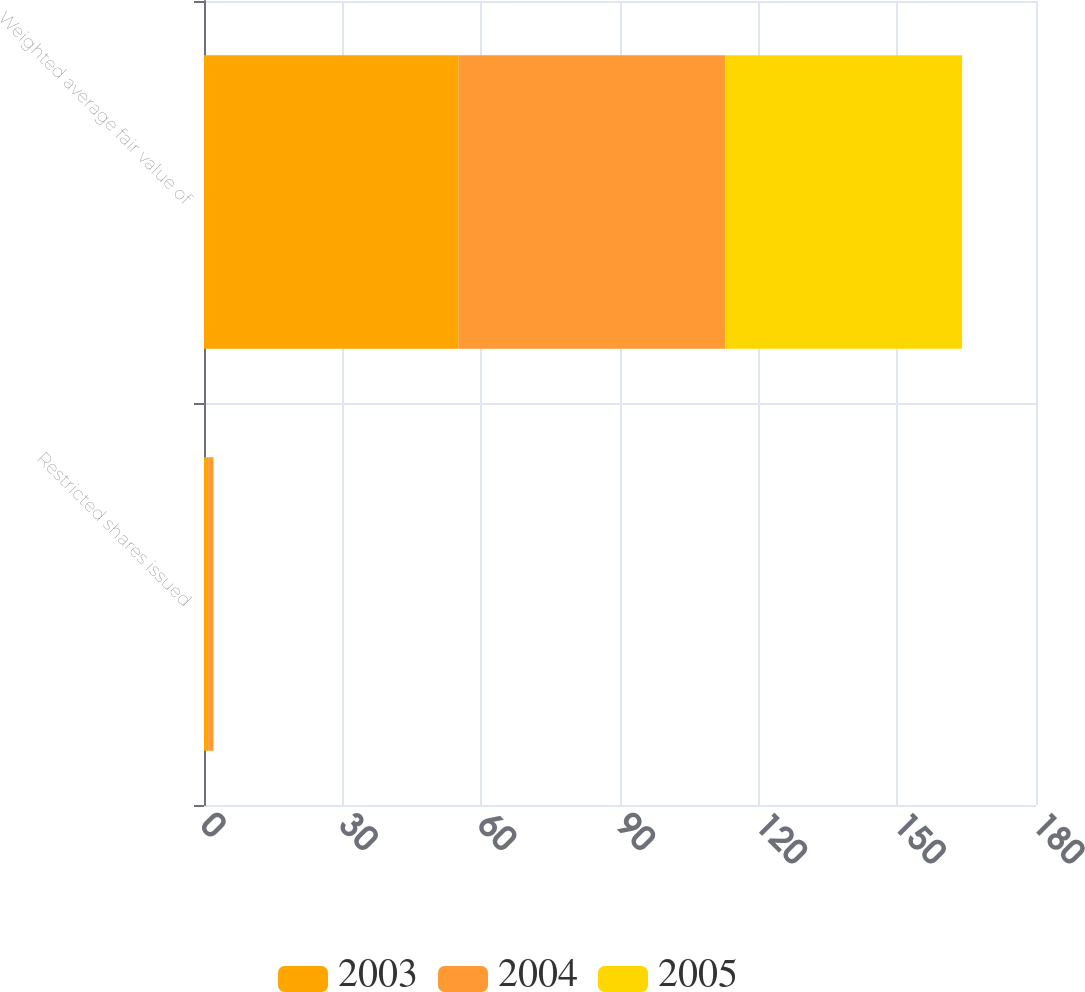<chart> <loc_0><loc_0><loc_500><loc_500><stacked_bar_chart><ecel><fcel>Restricted shares issued<fcel>Weighted average fair value of<nl><fcel>2003<fcel>0.9<fcel>55.09<nl><fcel>2004<fcel>1.1<fcel>57.65<nl><fcel>2005<fcel>0.1<fcel>51.27<nl></chart> 